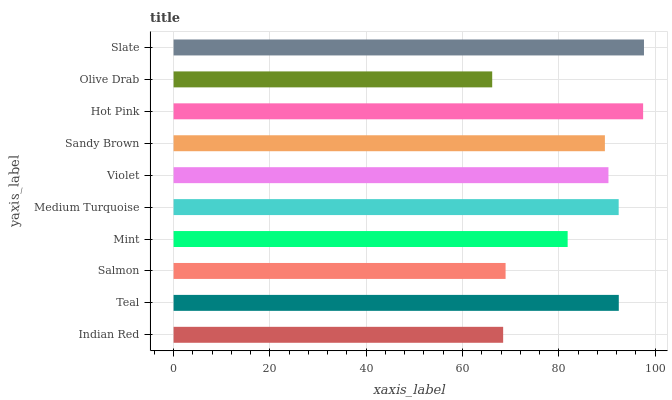Is Olive Drab the minimum?
Answer yes or no. Yes. Is Slate the maximum?
Answer yes or no. Yes. Is Teal the minimum?
Answer yes or no. No. Is Teal the maximum?
Answer yes or no. No. Is Teal greater than Indian Red?
Answer yes or no. Yes. Is Indian Red less than Teal?
Answer yes or no. Yes. Is Indian Red greater than Teal?
Answer yes or no. No. Is Teal less than Indian Red?
Answer yes or no. No. Is Violet the high median?
Answer yes or no. Yes. Is Sandy Brown the low median?
Answer yes or no. Yes. Is Sandy Brown the high median?
Answer yes or no. No. Is Olive Drab the low median?
Answer yes or no. No. 